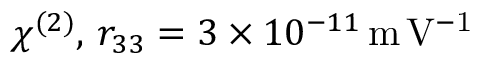Convert formula to latex. <formula><loc_0><loc_0><loc_500><loc_500>\chi ^ { ( 2 ) } , \, r _ { 3 3 } = 3 \times 1 0 ^ { - 1 1 } \, m \, V ^ { - 1 }</formula> 